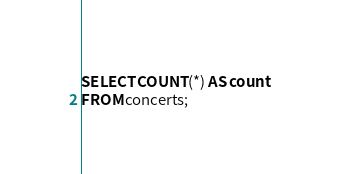Convert code to text. <code><loc_0><loc_0><loc_500><loc_500><_SQL_>SELECT COUNT(*) AS count
FROM concerts;
</code> 